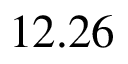<formula> <loc_0><loc_0><loc_500><loc_500>1 2 . 2 6</formula> 